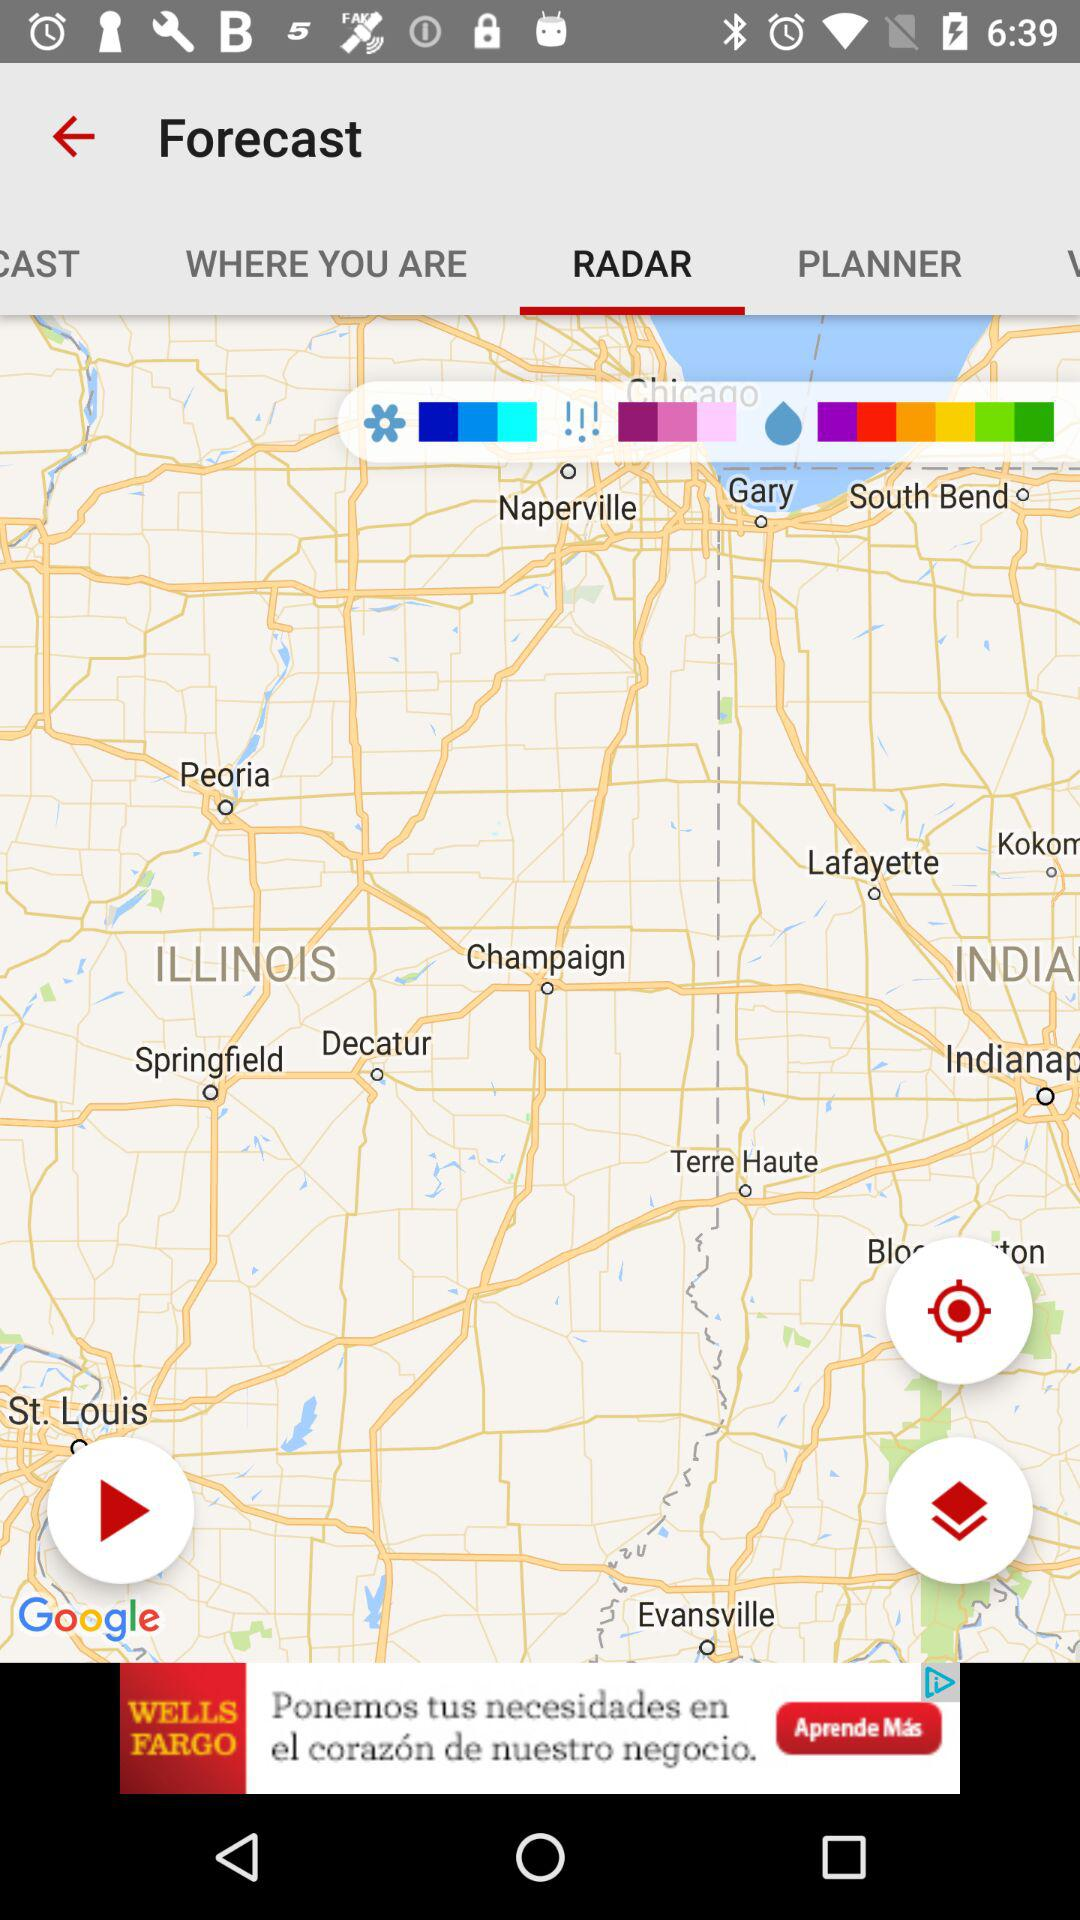Which tab is selected? The selected tab is Radar. 